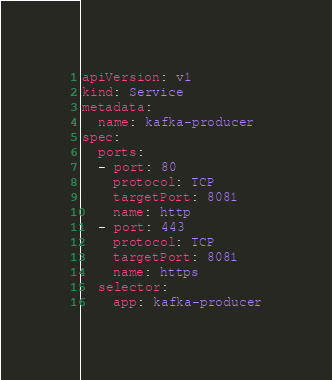Convert code to text. <code><loc_0><loc_0><loc_500><loc_500><_YAML_>apiVersion: v1
kind: Service
metadata:
  name: kafka-producer
spec:
  ports:
  - port: 80
    protocol: TCP
    targetPort: 8081
    name: http
  - port: 443
    protocol: TCP
    targetPort: 8081
    name: https
  selector:
    app: kafka-producer</code> 